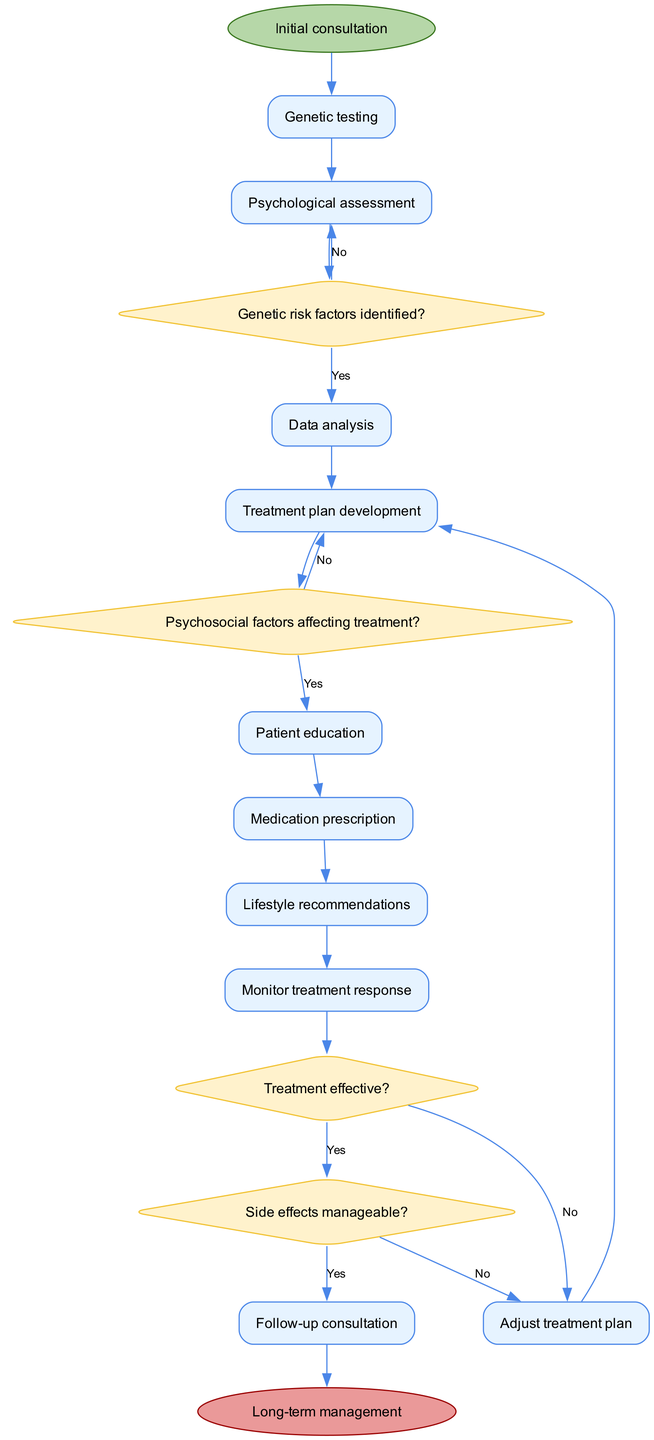What is the initial node of the diagram? The diagram starts with the "Initial consultation" node, which is represented as the first node in the flow of the activities.
Answer: Initial consultation How many activities are depicted in the diagram? The diagram includes a total of 9 activities, which are listed sequentially from the initial consultation through to patient education and medication prescription.
Answer: 9 Which decision follows the psychological assessment activity? After the "Psychological assessment" activity, the diagram leads to the "Genetic risk factors identified?" decision node, signifying the necessary evaluation of genetic testing results.
Answer: Genetic risk factors identified? What happens if genetic risk factors are not identified? If genetic risk factors are not identified, the flow directs back to the "Psychological assessment" activity, indicating a loop in the process for further evaluation.
Answer: Psychological assessment What is the last activity before the final node? The last activity prior to reaching the final node of "Long-term management" is the "Follow-up consultation," linking the treatment phase with ongoing management.
Answer: Follow-up consultation How many decision nodes are present in the diagram? The diagram contains a total of 4 decision nodes, each representing critical points in the patient journey that require evaluation or choices to guide the subsequent activities.
Answer: 4 What is the relationship between treatment success and adjustments to the treatment plan? If the treatment is determined to be ineffective ("Treatment effective?" decision), the flow redirects back to "Adjust treatment plan," ensuring that the patient's approach is revised as necessary for effectiveness.
Answer: Adjust treatment plan What edge connects the activity of genetic testing to the psychological assessment? The edge connecting "Genetic testing" to "Psychological assessment" is labeled "Analyze results," indicating a step in the analysis process after testing.
Answer: Analyze results What is the significance of the decision labeled "Side effects manageable?" This decision evaluates whether the side effects of the prescribed medication are manageable, which influences whether the treatment plan should be adjusted or continue as is.
Answer: Adjust treatment plan 